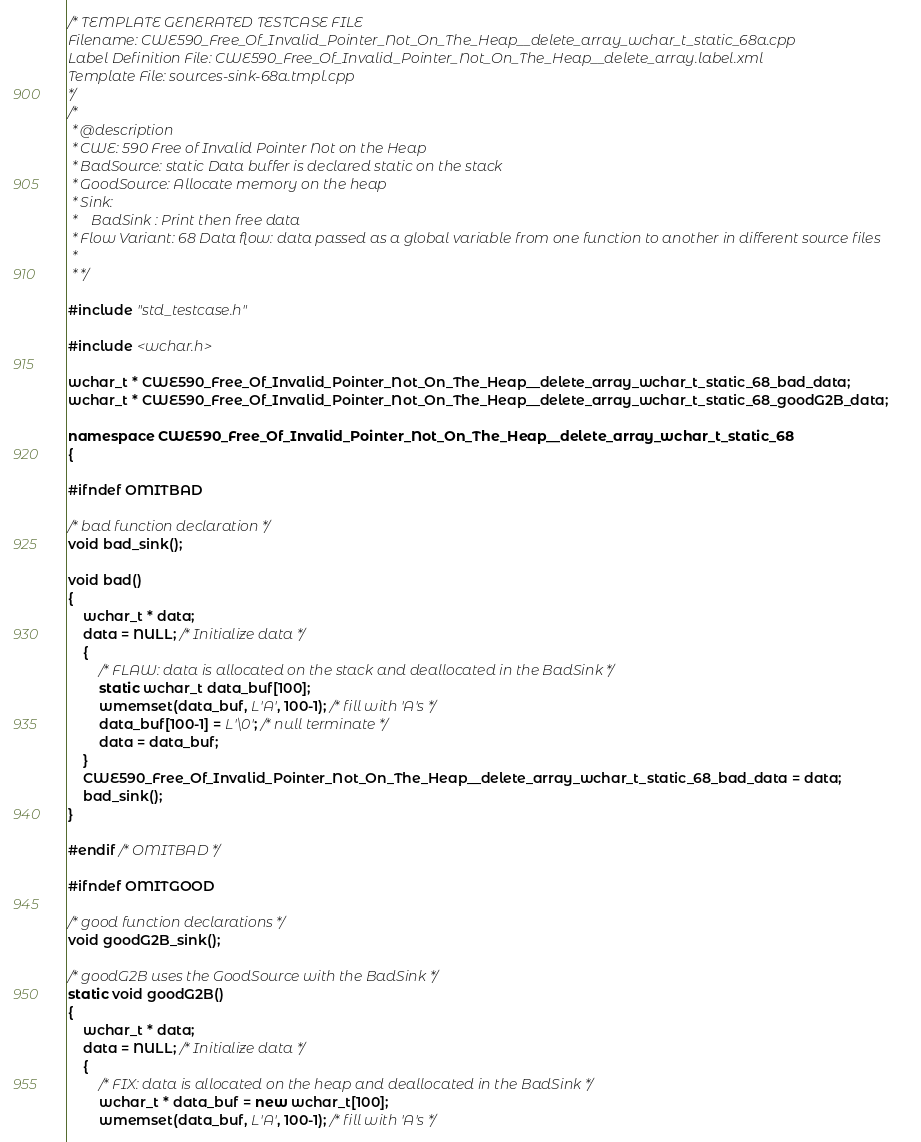Convert code to text. <code><loc_0><loc_0><loc_500><loc_500><_C++_>/* TEMPLATE GENERATED TESTCASE FILE
Filename: CWE590_Free_Of_Invalid_Pointer_Not_On_The_Heap__delete_array_wchar_t_static_68a.cpp
Label Definition File: CWE590_Free_Of_Invalid_Pointer_Not_On_The_Heap__delete_array.label.xml
Template File: sources-sink-68a.tmpl.cpp
*/
/*
 * @description
 * CWE: 590 Free of Invalid Pointer Not on the Heap
 * BadSource: static Data buffer is declared static on the stack
 * GoodSource: Allocate memory on the heap
 * Sink:
 *    BadSink : Print then free data
 * Flow Variant: 68 Data flow: data passed as a global variable from one function to another in different source files
 *
 * */

#include "std_testcase.h"

#include <wchar.h>

wchar_t * CWE590_Free_Of_Invalid_Pointer_Not_On_The_Heap__delete_array_wchar_t_static_68_bad_data;
wchar_t * CWE590_Free_Of_Invalid_Pointer_Not_On_The_Heap__delete_array_wchar_t_static_68_goodG2B_data;

namespace CWE590_Free_Of_Invalid_Pointer_Not_On_The_Heap__delete_array_wchar_t_static_68
{

#ifndef OMITBAD

/* bad function declaration */
void bad_sink();

void bad()
{
    wchar_t * data;
    data = NULL; /* Initialize data */
    {
        /* FLAW: data is allocated on the stack and deallocated in the BadSink */
        static wchar_t data_buf[100];
        wmemset(data_buf, L'A', 100-1); /* fill with 'A's */
        data_buf[100-1] = L'\0'; /* null terminate */
        data = data_buf;
    }
    CWE590_Free_Of_Invalid_Pointer_Not_On_The_Heap__delete_array_wchar_t_static_68_bad_data = data;
    bad_sink();
}

#endif /* OMITBAD */

#ifndef OMITGOOD

/* good function declarations */
void goodG2B_sink();

/* goodG2B uses the GoodSource with the BadSink */
static void goodG2B()
{
    wchar_t * data;
    data = NULL; /* Initialize data */
    {
        /* FIX: data is allocated on the heap and deallocated in the BadSink */
        wchar_t * data_buf = new wchar_t[100];
        wmemset(data_buf, L'A', 100-1); /* fill with 'A's */</code> 